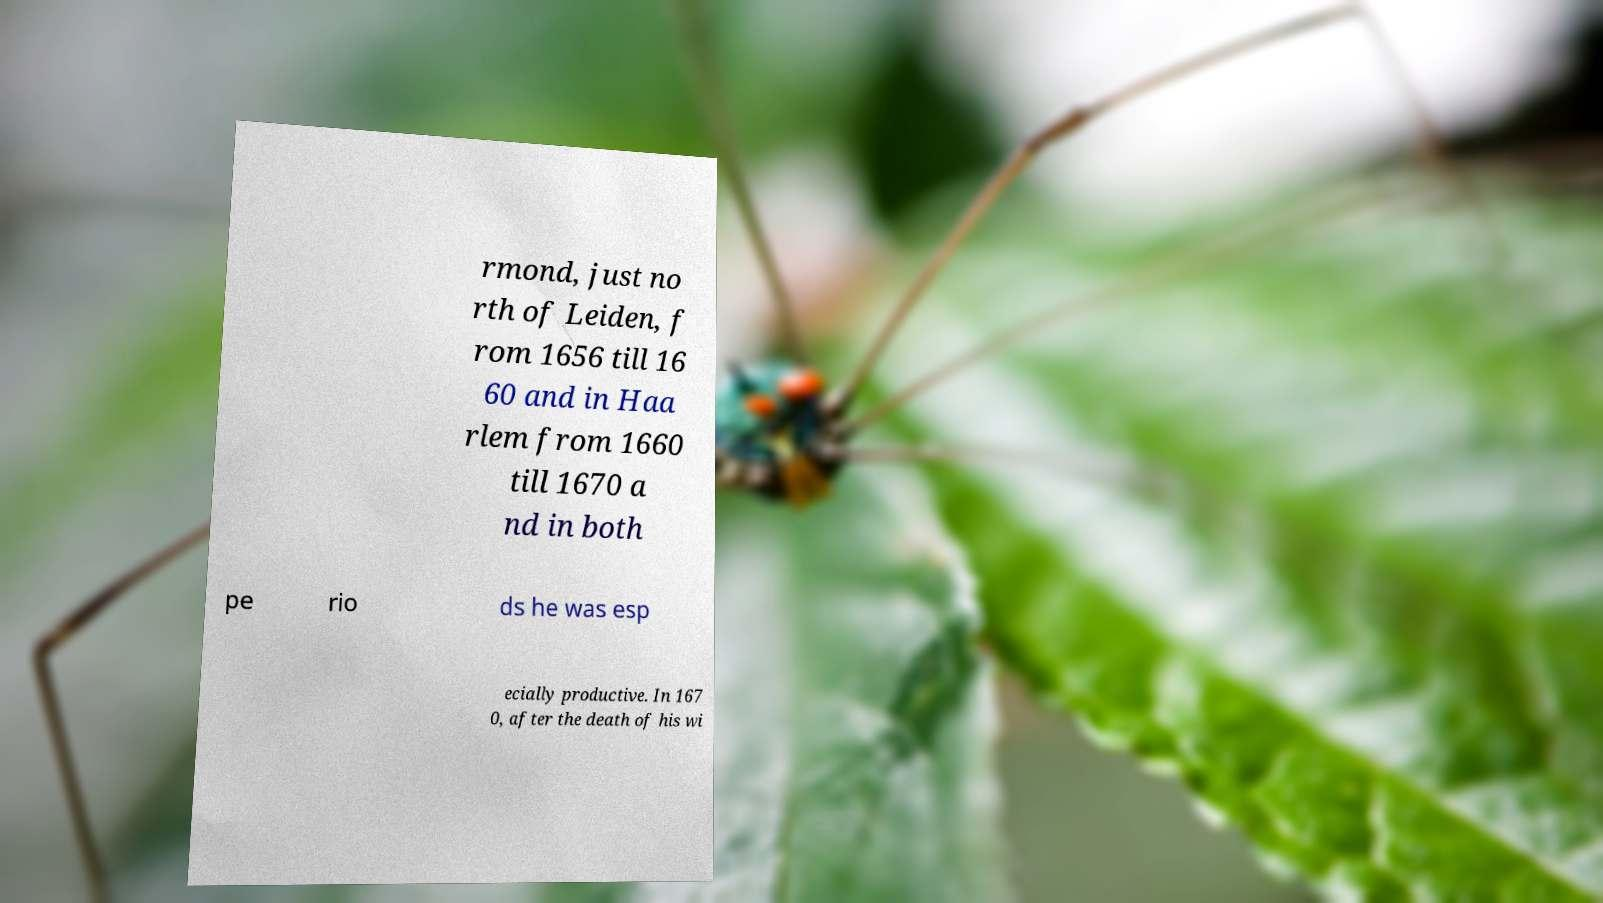I need the written content from this picture converted into text. Can you do that? rmond, just no rth of Leiden, f rom 1656 till 16 60 and in Haa rlem from 1660 till 1670 a nd in both pe rio ds he was esp ecially productive. In 167 0, after the death of his wi 